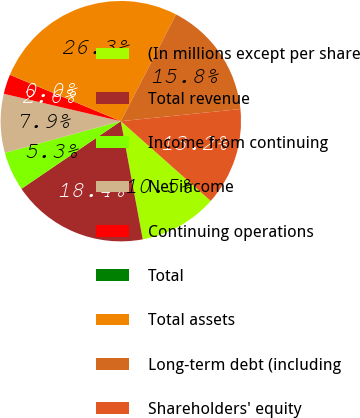Convert chart to OTSL. <chart><loc_0><loc_0><loc_500><loc_500><pie_chart><fcel>(In millions except per share<fcel>Total revenue<fcel>Income from continuing<fcel>Net income<fcel>Continuing operations<fcel>Total<fcel>Total assets<fcel>Long-term debt (including<fcel>Shareholders' equity<nl><fcel>10.53%<fcel>18.42%<fcel>5.27%<fcel>7.9%<fcel>2.64%<fcel>0.01%<fcel>26.3%<fcel>15.79%<fcel>13.16%<nl></chart> 